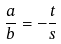Convert formula to latex. <formula><loc_0><loc_0><loc_500><loc_500>\frac { a } { b } = - \frac { t } { s }</formula> 